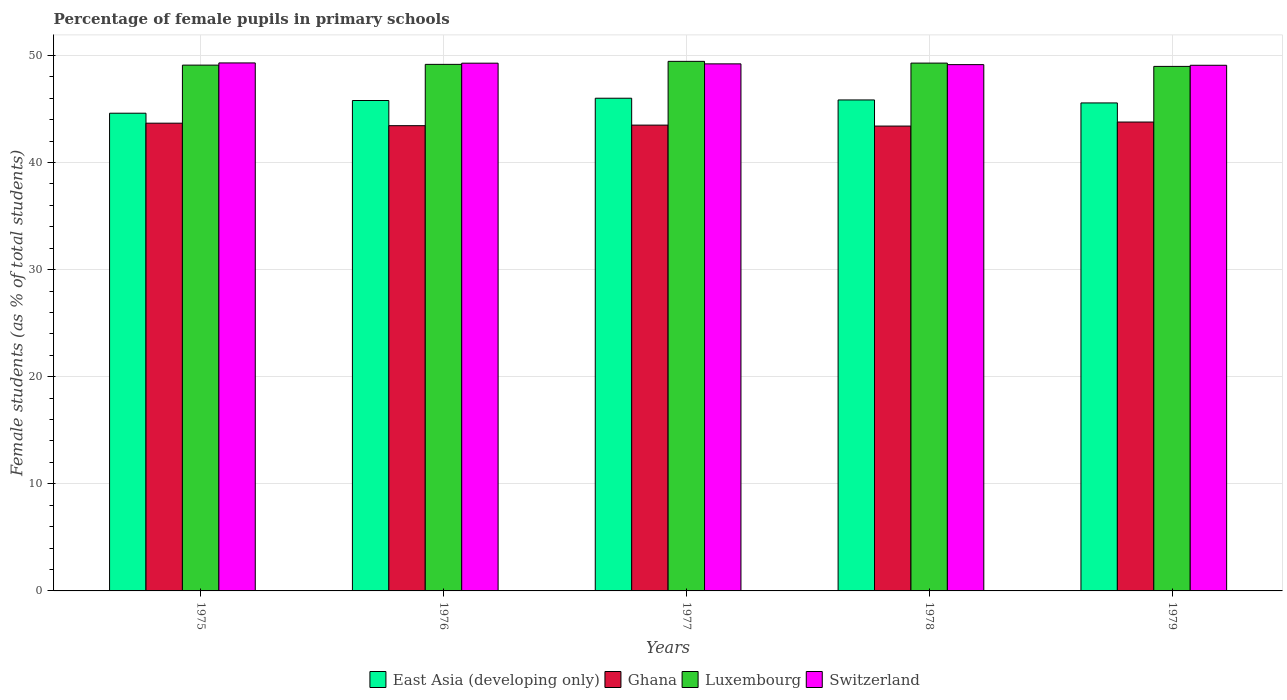How many different coloured bars are there?
Your answer should be very brief. 4. How many bars are there on the 4th tick from the right?
Provide a short and direct response. 4. What is the label of the 3rd group of bars from the left?
Your response must be concise. 1977. In how many cases, is the number of bars for a given year not equal to the number of legend labels?
Give a very brief answer. 0. What is the percentage of female pupils in primary schools in Luxembourg in 1977?
Your response must be concise. 49.44. Across all years, what is the maximum percentage of female pupils in primary schools in Luxembourg?
Your response must be concise. 49.44. Across all years, what is the minimum percentage of female pupils in primary schools in East Asia (developing only)?
Your response must be concise. 44.6. In which year was the percentage of female pupils in primary schools in Ghana maximum?
Offer a very short reply. 1979. In which year was the percentage of female pupils in primary schools in Ghana minimum?
Ensure brevity in your answer.  1978. What is the total percentage of female pupils in primary schools in Luxembourg in the graph?
Your answer should be compact. 245.94. What is the difference between the percentage of female pupils in primary schools in Luxembourg in 1976 and that in 1977?
Provide a short and direct response. -0.28. What is the difference between the percentage of female pupils in primary schools in East Asia (developing only) in 1975 and the percentage of female pupils in primary schools in Switzerland in 1978?
Ensure brevity in your answer.  -4.54. What is the average percentage of female pupils in primary schools in Ghana per year?
Provide a short and direct response. 43.55. In the year 1975, what is the difference between the percentage of female pupils in primary schools in Luxembourg and percentage of female pupils in primary schools in Ghana?
Your answer should be compact. 5.42. What is the ratio of the percentage of female pupils in primary schools in Luxembourg in 1977 to that in 1979?
Your response must be concise. 1.01. Is the percentage of female pupils in primary schools in Luxembourg in 1975 less than that in 1976?
Your answer should be very brief. Yes. What is the difference between the highest and the second highest percentage of female pupils in primary schools in Ghana?
Your answer should be compact. 0.11. What is the difference between the highest and the lowest percentage of female pupils in primary schools in East Asia (developing only)?
Give a very brief answer. 1.4. Is the sum of the percentage of female pupils in primary schools in East Asia (developing only) in 1978 and 1979 greater than the maximum percentage of female pupils in primary schools in Switzerland across all years?
Make the answer very short. Yes. Is it the case that in every year, the sum of the percentage of female pupils in primary schools in Ghana and percentage of female pupils in primary schools in Luxembourg is greater than the sum of percentage of female pupils in primary schools in East Asia (developing only) and percentage of female pupils in primary schools in Switzerland?
Offer a very short reply. Yes. What does the 2nd bar from the left in 1977 represents?
Offer a very short reply. Ghana. Is it the case that in every year, the sum of the percentage of female pupils in primary schools in Luxembourg and percentage of female pupils in primary schools in Switzerland is greater than the percentage of female pupils in primary schools in East Asia (developing only)?
Offer a very short reply. Yes. How many bars are there?
Your answer should be compact. 20. How many legend labels are there?
Provide a short and direct response. 4. How are the legend labels stacked?
Your response must be concise. Horizontal. What is the title of the graph?
Your answer should be compact. Percentage of female pupils in primary schools. What is the label or title of the Y-axis?
Offer a terse response. Female students (as % of total students). What is the Female students (as % of total students) of East Asia (developing only) in 1975?
Offer a very short reply. 44.6. What is the Female students (as % of total students) of Ghana in 1975?
Keep it short and to the point. 43.67. What is the Female students (as % of total students) in Luxembourg in 1975?
Your answer should be very brief. 49.09. What is the Female students (as % of total students) of Switzerland in 1975?
Provide a short and direct response. 49.3. What is the Female students (as % of total students) in East Asia (developing only) in 1976?
Give a very brief answer. 45.79. What is the Female students (as % of total students) of Ghana in 1976?
Ensure brevity in your answer.  43.44. What is the Female students (as % of total students) of Luxembourg in 1976?
Give a very brief answer. 49.16. What is the Female students (as % of total students) in Switzerland in 1976?
Give a very brief answer. 49.27. What is the Female students (as % of total students) of East Asia (developing only) in 1977?
Give a very brief answer. 46. What is the Female students (as % of total students) of Ghana in 1977?
Provide a short and direct response. 43.49. What is the Female students (as % of total students) of Luxembourg in 1977?
Your answer should be very brief. 49.44. What is the Female students (as % of total students) in Switzerland in 1977?
Provide a succinct answer. 49.21. What is the Female students (as % of total students) in East Asia (developing only) in 1978?
Ensure brevity in your answer.  45.84. What is the Female students (as % of total students) in Ghana in 1978?
Provide a succinct answer. 43.4. What is the Female students (as % of total students) in Luxembourg in 1978?
Your response must be concise. 49.28. What is the Female students (as % of total students) in Switzerland in 1978?
Make the answer very short. 49.14. What is the Female students (as % of total students) of East Asia (developing only) in 1979?
Make the answer very short. 45.56. What is the Female students (as % of total students) of Ghana in 1979?
Offer a very short reply. 43.78. What is the Female students (as % of total students) in Luxembourg in 1979?
Provide a succinct answer. 48.97. What is the Female students (as % of total students) of Switzerland in 1979?
Your response must be concise. 49.08. Across all years, what is the maximum Female students (as % of total students) of East Asia (developing only)?
Your answer should be compact. 46. Across all years, what is the maximum Female students (as % of total students) of Ghana?
Your response must be concise. 43.78. Across all years, what is the maximum Female students (as % of total students) of Luxembourg?
Your answer should be very brief. 49.44. Across all years, what is the maximum Female students (as % of total students) in Switzerland?
Provide a succinct answer. 49.3. Across all years, what is the minimum Female students (as % of total students) of East Asia (developing only)?
Provide a succinct answer. 44.6. Across all years, what is the minimum Female students (as % of total students) of Ghana?
Provide a short and direct response. 43.4. Across all years, what is the minimum Female students (as % of total students) of Luxembourg?
Keep it short and to the point. 48.97. Across all years, what is the minimum Female students (as % of total students) in Switzerland?
Give a very brief answer. 49.08. What is the total Female students (as % of total students) of East Asia (developing only) in the graph?
Offer a terse response. 227.79. What is the total Female students (as % of total students) of Ghana in the graph?
Provide a succinct answer. 217.77. What is the total Female students (as % of total students) in Luxembourg in the graph?
Keep it short and to the point. 245.94. What is the total Female students (as % of total students) of Switzerland in the graph?
Offer a very short reply. 245.99. What is the difference between the Female students (as % of total students) of East Asia (developing only) in 1975 and that in 1976?
Keep it short and to the point. -1.19. What is the difference between the Female students (as % of total students) in Ghana in 1975 and that in 1976?
Your answer should be compact. 0.23. What is the difference between the Female students (as % of total students) of Luxembourg in 1975 and that in 1976?
Make the answer very short. -0.07. What is the difference between the Female students (as % of total students) of Switzerland in 1975 and that in 1976?
Your response must be concise. 0.02. What is the difference between the Female students (as % of total students) in East Asia (developing only) in 1975 and that in 1977?
Your answer should be very brief. -1.4. What is the difference between the Female students (as % of total students) in Ghana in 1975 and that in 1977?
Provide a succinct answer. 0.18. What is the difference between the Female students (as % of total students) of Luxembourg in 1975 and that in 1977?
Ensure brevity in your answer.  -0.35. What is the difference between the Female students (as % of total students) of Switzerland in 1975 and that in 1977?
Offer a terse response. 0.09. What is the difference between the Female students (as % of total students) in East Asia (developing only) in 1975 and that in 1978?
Ensure brevity in your answer.  -1.24. What is the difference between the Female students (as % of total students) in Ghana in 1975 and that in 1978?
Your answer should be very brief. 0.27. What is the difference between the Female students (as % of total students) of Luxembourg in 1975 and that in 1978?
Your answer should be compact. -0.19. What is the difference between the Female students (as % of total students) of Switzerland in 1975 and that in 1978?
Your answer should be very brief. 0.16. What is the difference between the Female students (as % of total students) in East Asia (developing only) in 1975 and that in 1979?
Offer a terse response. -0.96. What is the difference between the Female students (as % of total students) of Ghana in 1975 and that in 1979?
Ensure brevity in your answer.  -0.11. What is the difference between the Female students (as % of total students) in Luxembourg in 1975 and that in 1979?
Offer a very short reply. 0.12. What is the difference between the Female students (as % of total students) in Switzerland in 1975 and that in 1979?
Your response must be concise. 0.22. What is the difference between the Female students (as % of total students) of East Asia (developing only) in 1976 and that in 1977?
Offer a terse response. -0.21. What is the difference between the Female students (as % of total students) of Ghana in 1976 and that in 1977?
Make the answer very short. -0.05. What is the difference between the Female students (as % of total students) in Luxembourg in 1976 and that in 1977?
Give a very brief answer. -0.28. What is the difference between the Female students (as % of total students) of Switzerland in 1976 and that in 1977?
Your answer should be compact. 0.06. What is the difference between the Female students (as % of total students) of East Asia (developing only) in 1976 and that in 1978?
Your response must be concise. -0.05. What is the difference between the Female students (as % of total students) of Ghana in 1976 and that in 1978?
Your response must be concise. 0.04. What is the difference between the Female students (as % of total students) of Luxembourg in 1976 and that in 1978?
Your response must be concise. -0.12. What is the difference between the Female students (as % of total students) of Switzerland in 1976 and that in 1978?
Offer a terse response. 0.13. What is the difference between the Female students (as % of total students) in East Asia (developing only) in 1976 and that in 1979?
Your response must be concise. 0.23. What is the difference between the Female students (as % of total students) of Ghana in 1976 and that in 1979?
Provide a succinct answer. -0.34. What is the difference between the Female students (as % of total students) of Luxembourg in 1976 and that in 1979?
Offer a terse response. 0.19. What is the difference between the Female students (as % of total students) in Switzerland in 1976 and that in 1979?
Provide a succinct answer. 0.19. What is the difference between the Female students (as % of total students) in East Asia (developing only) in 1977 and that in 1978?
Ensure brevity in your answer.  0.16. What is the difference between the Female students (as % of total students) of Ghana in 1977 and that in 1978?
Ensure brevity in your answer.  0.09. What is the difference between the Female students (as % of total students) in Luxembourg in 1977 and that in 1978?
Provide a succinct answer. 0.16. What is the difference between the Female students (as % of total students) in Switzerland in 1977 and that in 1978?
Your answer should be compact. 0.07. What is the difference between the Female students (as % of total students) of East Asia (developing only) in 1977 and that in 1979?
Your answer should be very brief. 0.44. What is the difference between the Female students (as % of total students) in Ghana in 1977 and that in 1979?
Make the answer very short. -0.29. What is the difference between the Female students (as % of total students) in Luxembourg in 1977 and that in 1979?
Offer a very short reply. 0.47. What is the difference between the Female students (as % of total students) of Switzerland in 1977 and that in 1979?
Offer a very short reply. 0.13. What is the difference between the Female students (as % of total students) of East Asia (developing only) in 1978 and that in 1979?
Make the answer very short. 0.28. What is the difference between the Female students (as % of total students) of Ghana in 1978 and that in 1979?
Give a very brief answer. -0.38. What is the difference between the Female students (as % of total students) of Luxembourg in 1978 and that in 1979?
Ensure brevity in your answer.  0.31. What is the difference between the Female students (as % of total students) in Switzerland in 1978 and that in 1979?
Provide a short and direct response. 0.06. What is the difference between the Female students (as % of total students) of East Asia (developing only) in 1975 and the Female students (as % of total students) of Ghana in 1976?
Provide a short and direct response. 1.16. What is the difference between the Female students (as % of total students) in East Asia (developing only) in 1975 and the Female students (as % of total students) in Luxembourg in 1976?
Make the answer very short. -4.56. What is the difference between the Female students (as % of total students) in East Asia (developing only) in 1975 and the Female students (as % of total students) in Switzerland in 1976?
Give a very brief answer. -4.67. What is the difference between the Female students (as % of total students) in Ghana in 1975 and the Female students (as % of total students) in Luxembourg in 1976?
Keep it short and to the point. -5.49. What is the difference between the Female students (as % of total students) in Ghana in 1975 and the Female students (as % of total students) in Switzerland in 1976?
Offer a very short reply. -5.6. What is the difference between the Female students (as % of total students) of Luxembourg in 1975 and the Female students (as % of total students) of Switzerland in 1976?
Make the answer very short. -0.18. What is the difference between the Female students (as % of total students) of East Asia (developing only) in 1975 and the Female students (as % of total students) of Ghana in 1977?
Make the answer very short. 1.11. What is the difference between the Female students (as % of total students) of East Asia (developing only) in 1975 and the Female students (as % of total students) of Luxembourg in 1977?
Offer a very short reply. -4.84. What is the difference between the Female students (as % of total students) of East Asia (developing only) in 1975 and the Female students (as % of total students) of Switzerland in 1977?
Provide a short and direct response. -4.61. What is the difference between the Female students (as % of total students) of Ghana in 1975 and the Female students (as % of total students) of Luxembourg in 1977?
Provide a short and direct response. -5.77. What is the difference between the Female students (as % of total students) in Ghana in 1975 and the Female students (as % of total students) in Switzerland in 1977?
Offer a terse response. -5.54. What is the difference between the Female students (as % of total students) in Luxembourg in 1975 and the Female students (as % of total students) in Switzerland in 1977?
Offer a terse response. -0.12. What is the difference between the Female students (as % of total students) in East Asia (developing only) in 1975 and the Female students (as % of total students) in Ghana in 1978?
Make the answer very short. 1.2. What is the difference between the Female students (as % of total students) of East Asia (developing only) in 1975 and the Female students (as % of total students) of Luxembourg in 1978?
Ensure brevity in your answer.  -4.68. What is the difference between the Female students (as % of total students) of East Asia (developing only) in 1975 and the Female students (as % of total students) of Switzerland in 1978?
Offer a very short reply. -4.54. What is the difference between the Female students (as % of total students) in Ghana in 1975 and the Female students (as % of total students) in Luxembourg in 1978?
Provide a succinct answer. -5.61. What is the difference between the Female students (as % of total students) of Ghana in 1975 and the Female students (as % of total students) of Switzerland in 1978?
Make the answer very short. -5.47. What is the difference between the Female students (as % of total students) of Luxembourg in 1975 and the Female students (as % of total students) of Switzerland in 1978?
Give a very brief answer. -0.05. What is the difference between the Female students (as % of total students) of East Asia (developing only) in 1975 and the Female students (as % of total students) of Ghana in 1979?
Your answer should be very brief. 0.82. What is the difference between the Female students (as % of total students) of East Asia (developing only) in 1975 and the Female students (as % of total students) of Luxembourg in 1979?
Your answer should be compact. -4.37. What is the difference between the Female students (as % of total students) of East Asia (developing only) in 1975 and the Female students (as % of total students) of Switzerland in 1979?
Give a very brief answer. -4.48. What is the difference between the Female students (as % of total students) in Ghana in 1975 and the Female students (as % of total students) in Luxembourg in 1979?
Offer a terse response. -5.3. What is the difference between the Female students (as % of total students) in Ghana in 1975 and the Female students (as % of total students) in Switzerland in 1979?
Your answer should be very brief. -5.41. What is the difference between the Female students (as % of total students) of Luxembourg in 1975 and the Female students (as % of total students) of Switzerland in 1979?
Ensure brevity in your answer.  0.01. What is the difference between the Female students (as % of total students) of East Asia (developing only) in 1976 and the Female students (as % of total students) of Ghana in 1977?
Provide a short and direct response. 2.3. What is the difference between the Female students (as % of total students) in East Asia (developing only) in 1976 and the Female students (as % of total students) in Luxembourg in 1977?
Your answer should be very brief. -3.65. What is the difference between the Female students (as % of total students) in East Asia (developing only) in 1976 and the Female students (as % of total students) in Switzerland in 1977?
Offer a terse response. -3.42. What is the difference between the Female students (as % of total students) in Ghana in 1976 and the Female students (as % of total students) in Luxembourg in 1977?
Your response must be concise. -6.01. What is the difference between the Female students (as % of total students) of Ghana in 1976 and the Female students (as % of total students) of Switzerland in 1977?
Make the answer very short. -5.77. What is the difference between the Female students (as % of total students) of Luxembourg in 1976 and the Female students (as % of total students) of Switzerland in 1977?
Provide a succinct answer. -0.05. What is the difference between the Female students (as % of total students) in East Asia (developing only) in 1976 and the Female students (as % of total students) in Ghana in 1978?
Your answer should be compact. 2.39. What is the difference between the Female students (as % of total students) in East Asia (developing only) in 1976 and the Female students (as % of total students) in Luxembourg in 1978?
Your response must be concise. -3.49. What is the difference between the Female students (as % of total students) of East Asia (developing only) in 1976 and the Female students (as % of total students) of Switzerland in 1978?
Make the answer very short. -3.35. What is the difference between the Female students (as % of total students) in Ghana in 1976 and the Female students (as % of total students) in Luxembourg in 1978?
Ensure brevity in your answer.  -5.84. What is the difference between the Female students (as % of total students) in Ghana in 1976 and the Female students (as % of total students) in Switzerland in 1978?
Ensure brevity in your answer.  -5.7. What is the difference between the Female students (as % of total students) in Luxembourg in 1976 and the Female students (as % of total students) in Switzerland in 1978?
Offer a terse response. 0.02. What is the difference between the Female students (as % of total students) in East Asia (developing only) in 1976 and the Female students (as % of total students) in Ghana in 1979?
Your response must be concise. 2.01. What is the difference between the Female students (as % of total students) of East Asia (developing only) in 1976 and the Female students (as % of total students) of Luxembourg in 1979?
Ensure brevity in your answer.  -3.18. What is the difference between the Female students (as % of total students) of East Asia (developing only) in 1976 and the Female students (as % of total students) of Switzerland in 1979?
Your answer should be compact. -3.29. What is the difference between the Female students (as % of total students) in Ghana in 1976 and the Female students (as % of total students) in Luxembourg in 1979?
Give a very brief answer. -5.54. What is the difference between the Female students (as % of total students) in Ghana in 1976 and the Female students (as % of total students) in Switzerland in 1979?
Give a very brief answer. -5.64. What is the difference between the Female students (as % of total students) of Luxembourg in 1976 and the Female students (as % of total students) of Switzerland in 1979?
Your response must be concise. 0.08. What is the difference between the Female students (as % of total students) in East Asia (developing only) in 1977 and the Female students (as % of total students) in Ghana in 1978?
Provide a succinct answer. 2.6. What is the difference between the Female students (as % of total students) of East Asia (developing only) in 1977 and the Female students (as % of total students) of Luxembourg in 1978?
Your answer should be compact. -3.28. What is the difference between the Female students (as % of total students) in East Asia (developing only) in 1977 and the Female students (as % of total students) in Switzerland in 1978?
Provide a succinct answer. -3.14. What is the difference between the Female students (as % of total students) of Ghana in 1977 and the Female students (as % of total students) of Luxembourg in 1978?
Offer a very short reply. -5.79. What is the difference between the Female students (as % of total students) of Ghana in 1977 and the Female students (as % of total students) of Switzerland in 1978?
Provide a succinct answer. -5.65. What is the difference between the Female students (as % of total students) in Luxembourg in 1977 and the Female students (as % of total students) in Switzerland in 1978?
Ensure brevity in your answer.  0.31. What is the difference between the Female students (as % of total students) in East Asia (developing only) in 1977 and the Female students (as % of total students) in Ghana in 1979?
Ensure brevity in your answer.  2.22. What is the difference between the Female students (as % of total students) of East Asia (developing only) in 1977 and the Female students (as % of total students) of Luxembourg in 1979?
Offer a very short reply. -2.97. What is the difference between the Female students (as % of total students) of East Asia (developing only) in 1977 and the Female students (as % of total students) of Switzerland in 1979?
Provide a succinct answer. -3.08. What is the difference between the Female students (as % of total students) of Ghana in 1977 and the Female students (as % of total students) of Luxembourg in 1979?
Give a very brief answer. -5.48. What is the difference between the Female students (as % of total students) of Ghana in 1977 and the Female students (as % of total students) of Switzerland in 1979?
Offer a terse response. -5.59. What is the difference between the Female students (as % of total students) in Luxembourg in 1977 and the Female students (as % of total students) in Switzerland in 1979?
Offer a terse response. 0.37. What is the difference between the Female students (as % of total students) in East Asia (developing only) in 1978 and the Female students (as % of total students) in Ghana in 1979?
Keep it short and to the point. 2.06. What is the difference between the Female students (as % of total students) of East Asia (developing only) in 1978 and the Female students (as % of total students) of Luxembourg in 1979?
Offer a very short reply. -3.13. What is the difference between the Female students (as % of total students) of East Asia (developing only) in 1978 and the Female students (as % of total students) of Switzerland in 1979?
Give a very brief answer. -3.24. What is the difference between the Female students (as % of total students) in Ghana in 1978 and the Female students (as % of total students) in Luxembourg in 1979?
Your response must be concise. -5.57. What is the difference between the Female students (as % of total students) in Ghana in 1978 and the Female students (as % of total students) in Switzerland in 1979?
Your answer should be very brief. -5.68. What is the difference between the Female students (as % of total students) in Luxembourg in 1978 and the Female students (as % of total students) in Switzerland in 1979?
Provide a succinct answer. 0.2. What is the average Female students (as % of total students) in East Asia (developing only) per year?
Keep it short and to the point. 45.56. What is the average Female students (as % of total students) in Ghana per year?
Ensure brevity in your answer.  43.55. What is the average Female students (as % of total students) of Luxembourg per year?
Ensure brevity in your answer.  49.19. What is the average Female students (as % of total students) in Switzerland per year?
Your response must be concise. 49.2. In the year 1975, what is the difference between the Female students (as % of total students) of East Asia (developing only) and Female students (as % of total students) of Ghana?
Offer a very short reply. 0.93. In the year 1975, what is the difference between the Female students (as % of total students) of East Asia (developing only) and Female students (as % of total students) of Luxembourg?
Give a very brief answer. -4.49. In the year 1975, what is the difference between the Female students (as % of total students) in East Asia (developing only) and Female students (as % of total students) in Switzerland?
Your answer should be compact. -4.69. In the year 1975, what is the difference between the Female students (as % of total students) of Ghana and Female students (as % of total students) of Luxembourg?
Offer a very short reply. -5.42. In the year 1975, what is the difference between the Female students (as % of total students) in Ghana and Female students (as % of total students) in Switzerland?
Ensure brevity in your answer.  -5.63. In the year 1975, what is the difference between the Female students (as % of total students) in Luxembourg and Female students (as % of total students) in Switzerland?
Offer a very short reply. -0.2. In the year 1976, what is the difference between the Female students (as % of total students) of East Asia (developing only) and Female students (as % of total students) of Ghana?
Ensure brevity in your answer.  2.35. In the year 1976, what is the difference between the Female students (as % of total students) of East Asia (developing only) and Female students (as % of total students) of Luxembourg?
Offer a terse response. -3.37. In the year 1976, what is the difference between the Female students (as % of total students) of East Asia (developing only) and Female students (as % of total students) of Switzerland?
Offer a terse response. -3.48. In the year 1976, what is the difference between the Female students (as % of total students) of Ghana and Female students (as % of total students) of Luxembourg?
Offer a very short reply. -5.72. In the year 1976, what is the difference between the Female students (as % of total students) of Ghana and Female students (as % of total students) of Switzerland?
Provide a short and direct response. -5.84. In the year 1976, what is the difference between the Female students (as % of total students) of Luxembourg and Female students (as % of total students) of Switzerland?
Provide a short and direct response. -0.11. In the year 1977, what is the difference between the Female students (as % of total students) in East Asia (developing only) and Female students (as % of total students) in Ghana?
Give a very brief answer. 2.51. In the year 1977, what is the difference between the Female students (as % of total students) of East Asia (developing only) and Female students (as % of total students) of Luxembourg?
Your answer should be compact. -3.44. In the year 1977, what is the difference between the Female students (as % of total students) in East Asia (developing only) and Female students (as % of total students) in Switzerland?
Ensure brevity in your answer.  -3.21. In the year 1977, what is the difference between the Female students (as % of total students) of Ghana and Female students (as % of total students) of Luxembourg?
Keep it short and to the point. -5.95. In the year 1977, what is the difference between the Female students (as % of total students) of Ghana and Female students (as % of total students) of Switzerland?
Your answer should be very brief. -5.72. In the year 1977, what is the difference between the Female students (as % of total students) of Luxembourg and Female students (as % of total students) of Switzerland?
Offer a terse response. 0.23. In the year 1978, what is the difference between the Female students (as % of total students) in East Asia (developing only) and Female students (as % of total students) in Ghana?
Offer a terse response. 2.44. In the year 1978, what is the difference between the Female students (as % of total students) in East Asia (developing only) and Female students (as % of total students) in Luxembourg?
Your response must be concise. -3.44. In the year 1978, what is the difference between the Female students (as % of total students) in East Asia (developing only) and Female students (as % of total students) in Switzerland?
Your answer should be compact. -3.3. In the year 1978, what is the difference between the Female students (as % of total students) in Ghana and Female students (as % of total students) in Luxembourg?
Offer a very short reply. -5.88. In the year 1978, what is the difference between the Female students (as % of total students) in Ghana and Female students (as % of total students) in Switzerland?
Your response must be concise. -5.74. In the year 1978, what is the difference between the Female students (as % of total students) in Luxembourg and Female students (as % of total students) in Switzerland?
Provide a short and direct response. 0.14. In the year 1979, what is the difference between the Female students (as % of total students) in East Asia (developing only) and Female students (as % of total students) in Ghana?
Offer a terse response. 1.78. In the year 1979, what is the difference between the Female students (as % of total students) in East Asia (developing only) and Female students (as % of total students) in Luxembourg?
Offer a very short reply. -3.41. In the year 1979, what is the difference between the Female students (as % of total students) of East Asia (developing only) and Female students (as % of total students) of Switzerland?
Provide a short and direct response. -3.52. In the year 1979, what is the difference between the Female students (as % of total students) of Ghana and Female students (as % of total students) of Luxembourg?
Provide a short and direct response. -5.2. In the year 1979, what is the difference between the Female students (as % of total students) in Ghana and Female students (as % of total students) in Switzerland?
Your response must be concise. -5.3. In the year 1979, what is the difference between the Female students (as % of total students) in Luxembourg and Female students (as % of total students) in Switzerland?
Your answer should be compact. -0.1. What is the ratio of the Female students (as % of total students) in East Asia (developing only) in 1975 to that in 1976?
Provide a succinct answer. 0.97. What is the ratio of the Female students (as % of total students) in Ghana in 1975 to that in 1976?
Your answer should be compact. 1.01. What is the ratio of the Female students (as % of total students) of East Asia (developing only) in 1975 to that in 1977?
Keep it short and to the point. 0.97. What is the ratio of the Female students (as % of total students) in Luxembourg in 1975 to that in 1977?
Ensure brevity in your answer.  0.99. What is the ratio of the Female students (as % of total students) of Ghana in 1975 to that in 1978?
Provide a succinct answer. 1.01. What is the ratio of the Female students (as % of total students) of Luxembourg in 1975 to that in 1978?
Your answer should be compact. 1. What is the ratio of the Female students (as % of total students) of East Asia (developing only) in 1975 to that in 1979?
Provide a succinct answer. 0.98. What is the ratio of the Female students (as % of total students) in Ghana in 1975 to that in 1979?
Give a very brief answer. 1. What is the ratio of the Female students (as % of total students) of Ghana in 1976 to that in 1977?
Ensure brevity in your answer.  1. What is the ratio of the Female students (as % of total students) of Switzerland in 1976 to that in 1977?
Your answer should be compact. 1. What is the ratio of the Female students (as % of total students) of Luxembourg in 1976 to that in 1978?
Make the answer very short. 1. What is the ratio of the Female students (as % of total students) in Switzerland in 1976 to that in 1978?
Ensure brevity in your answer.  1. What is the ratio of the Female students (as % of total students) of Luxembourg in 1976 to that in 1979?
Your response must be concise. 1. What is the ratio of the Female students (as % of total students) in Switzerland in 1976 to that in 1979?
Your answer should be compact. 1. What is the ratio of the Female students (as % of total students) in East Asia (developing only) in 1977 to that in 1978?
Offer a terse response. 1. What is the ratio of the Female students (as % of total students) in Ghana in 1977 to that in 1978?
Offer a very short reply. 1. What is the ratio of the Female students (as % of total students) in Luxembourg in 1977 to that in 1978?
Offer a very short reply. 1. What is the ratio of the Female students (as % of total students) in Switzerland in 1977 to that in 1978?
Offer a terse response. 1. What is the ratio of the Female students (as % of total students) in East Asia (developing only) in 1977 to that in 1979?
Offer a very short reply. 1.01. What is the ratio of the Female students (as % of total students) of Luxembourg in 1977 to that in 1979?
Your answer should be compact. 1.01. What is the ratio of the Female students (as % of total students) in East Asia (developing only) in 1978 to that in 1979?
Give a very brief answer. 1.01. What is the ratio of the Female students (as % of total students) in Switzerland in 1978 to that in 1979?
Make the answer very short. 1. What is the difference between the highest and the second highest Female students (as % of total students) of East Asia (developing only)?
Offer a terse response. 0.16. What is the difference between the highest and the second highest Female students (as % of total students) of Ghana?
Give a very brief answer. 0.11. What is the difference between the highest and the second highest Female students (as % of total students) of Luxembourg?
Your response must be concise. 0.16. What is the difference between the highest and the second highest Female students (as % of total students) of Switzerland?
Offer a very short reply. 0.02. What is the difference between the highest and the lowest Female students (as % of total students) of East Asia (developing only)?
Your answer should be compact. 1.4. What is the difference between the highest and the lowest Female students (as % of total students) in Ghana?
Keep it short and to the point. 0.38. What is the difference between the highest and the lowest Female students (as % of total students) of Luxembourg?
Ensure brevity in your answer.  0.47. What is the difference between the highest and the lowest Female students (as % of total students) of Switzerland?
Provide a short and direct response. 0.22. 